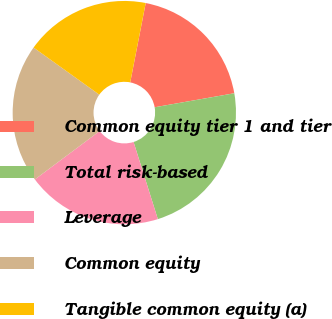Convert chart to OTSL. <chart><loc_0><loc_0><loc_500><loc_500><pie_chart><fcel>Common equity tier 1 and tier<fcel>Total risk-based<fcel>Leverage<fcel>Common equity<fcel>Tangible common equity (a)<nl><fcel>19.16%<fcel>22.92%<fcel>19.64%<fcel>20.11%<fcel>18.17%<nl></chart> 